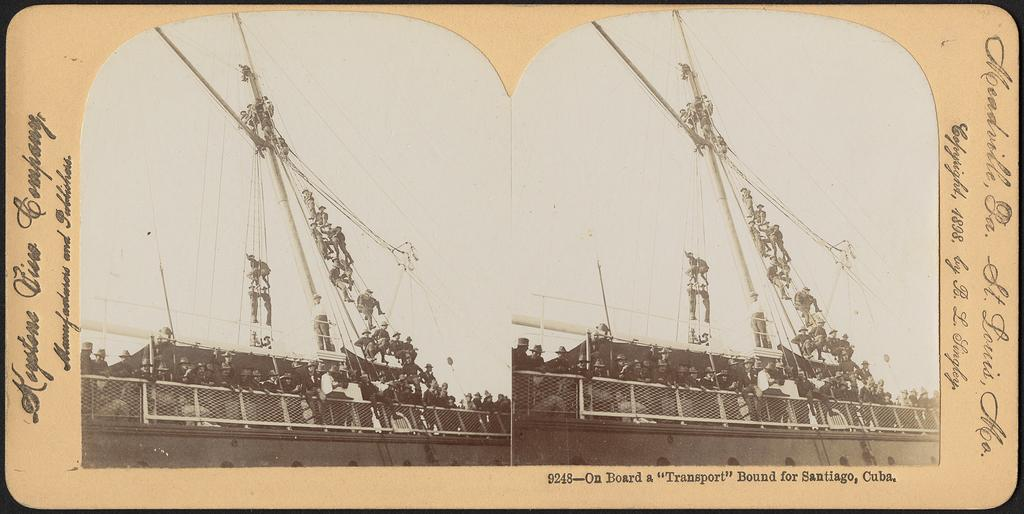What is the color scheme of the poster in the image? The poster is black and white. What is depicted on the poster besides the color scheme? There is text written on the poster and a picture of a boat. What are the people in the picture doing? There are people climbing up the boat in the picture. What type of lettuce is being used as a vegetable in the image? There is no lettuce or vegetable present in the image; it features a poster with a picture of a boat and people climbing it. 